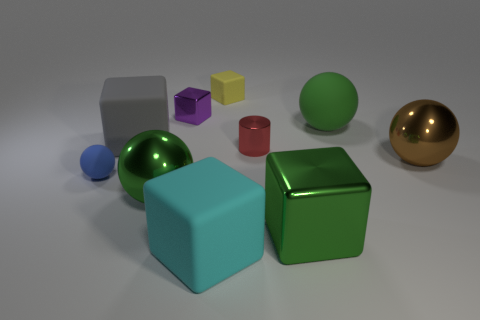Subtract 2 spheres. How many spheres are left? 2 Subtract all tiny matte blocks. How many blocks are left? 4 Subtract all purple cubes. How many cubes are left? 4 Subtract all red blocks. Subtract all blue spheres. How many blocks are left? 5 Subtract all cylinders. How many objects are left? 9 Add 1 tiny red cylinders. How many tiny red cylinders exist? 2 Subtract 1 blue balls. How many objects are left? 9 Subtract all big matte things. Subtract all tiny purple shiny cubes. How many objects are left? 6 Add 2 blue rubber things. How many blue rubber things are left? 3 